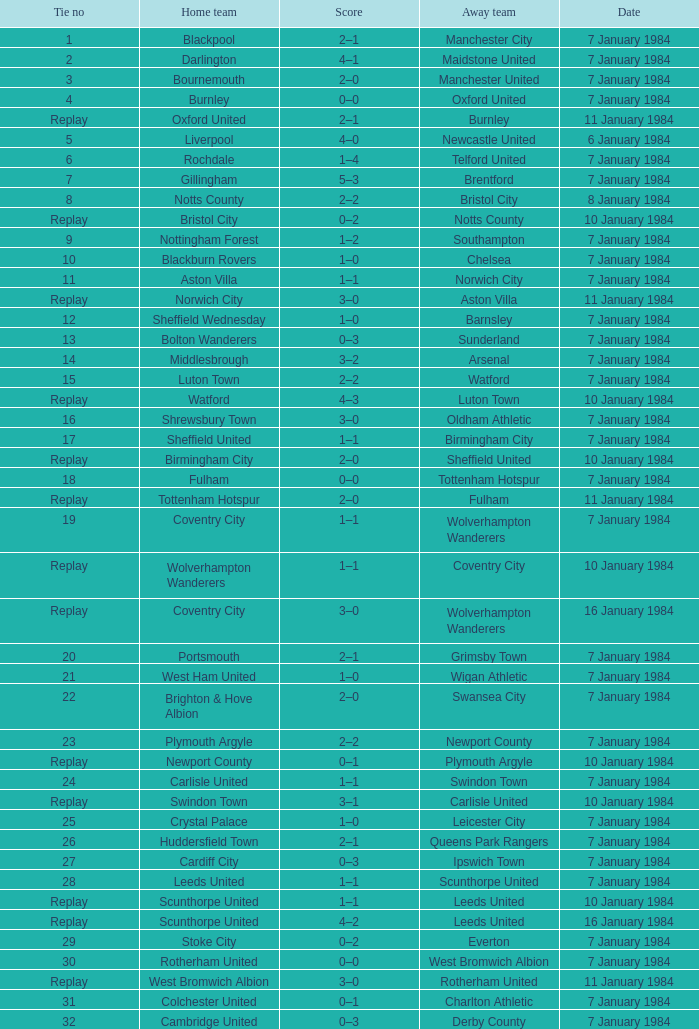Against sheffield united as the home team, who was the opposing away team? Birmingham City. 